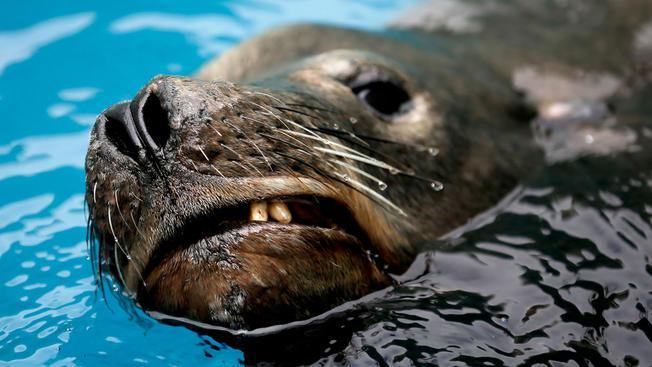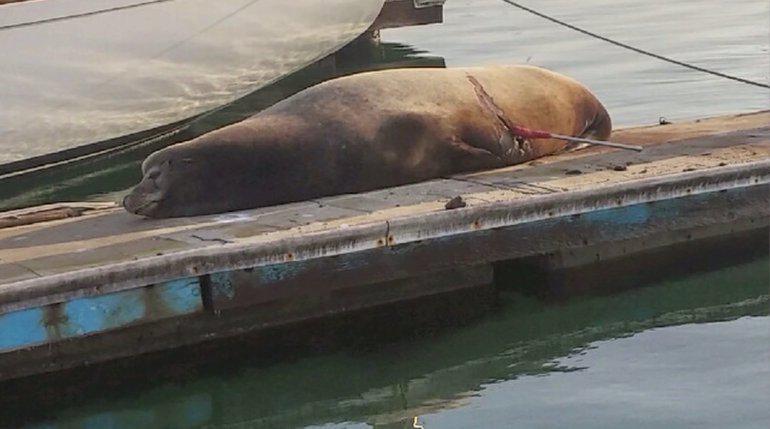The first image is the image on the left, the second image is the image on the right. Examine the images to the left and right. Is the description "An image shows seals lying on a pier that has a narrow section extending out." accurate? Answer yes or no. No. The first image is the image on the left, the second image is the image on the right. For the images displayed, is the sentence "One of the sea animals is lying on a wharf near the water." factually correct? Answer yes or no. Yes. 